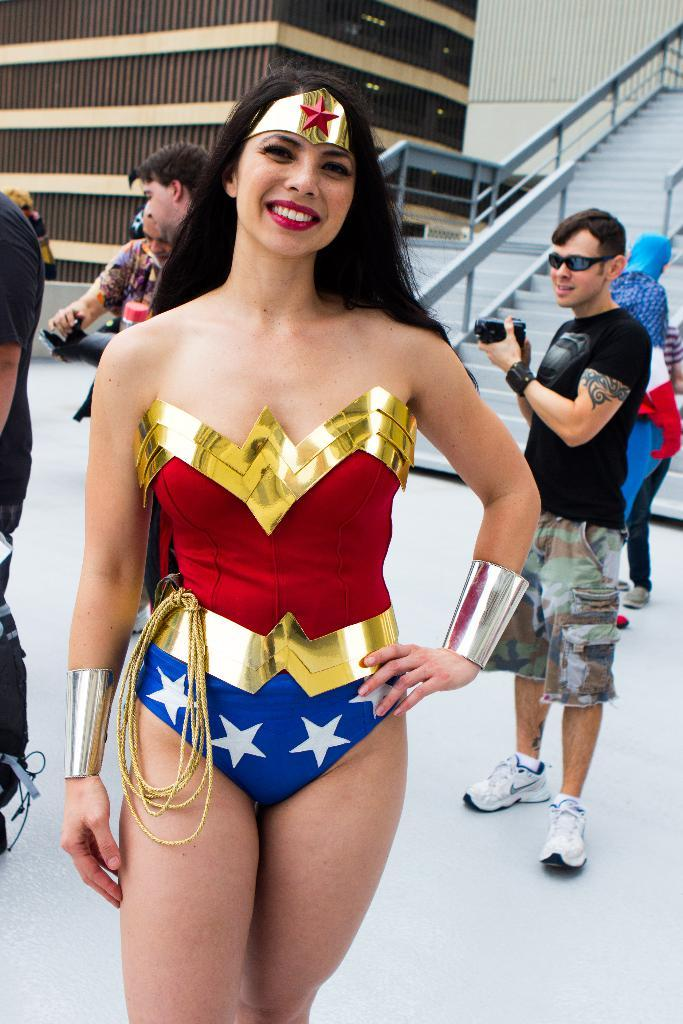What is the main subject in the foreground of the image? There is a woman standing and posing in the foreground of the image. What can be seen in the background of the image? There are persons standing in the background of the image, as well as stairs and buildings. What word is the woman saying in the image? There is no indication in the image of what the woman might be saying, so it cannot be determined from the picture. 